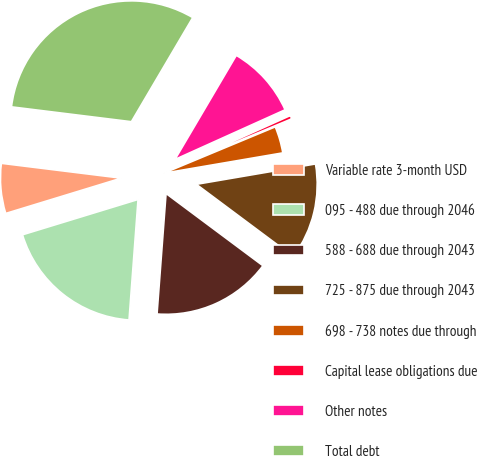<chart> <loc_0><loc_0><loc_500><loc_500><pie_chart><fcel>Variable rate 3-month USD<fcel>095 - 488 due through 2046<fcel>588 - 688 due through 2043<fcel>725 - 875 due through 2043<fcel>698 - 738 notes due through<fcel>Capital lease obligations due<fcel>Other notes<fcel>Total debt<nl><fcel>6.68%<fcel>19.09%<fcel>15.99%<fcel>12.89%<fcel>3.58%<fcel>0.47%<fcel>9.78%<fcel>31.51%<nl></chart> 